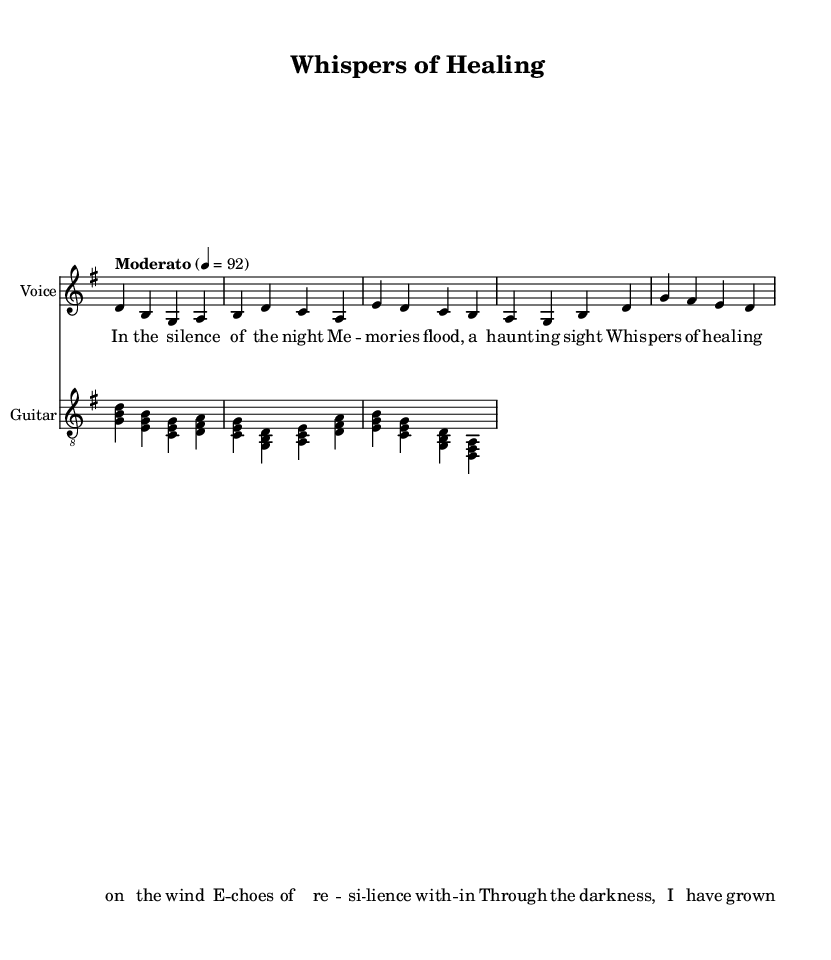What is the key signature of this music? The key signature is G major, which has one sharp (F#). This can be confirmed by looking at the key signature at the beginning of the score.
Answer: G major What is the time signature of this music? The time signature is 4/4, indicated by the notation present at the beginning of the piece. This means there are four beats in each measure.
Answer: 4/4 What is the tempo marking for this piece? The tempo marking indicates "Moderato," which generally suggests a moderate speed. It is specified in the tempo text above the staff, and the corresponding metronome marking is 92.
Answer: Moderato How many measures are in the verse? The verse consists of four measures. By counting the sets of vertical lines (bar lines) between the measures, we can determine there are four distinct measures present in the verse.
Answer: 4 What chord follows the G chord in the chorus? The chord that follows the G chord in the chorus is the A chord. This can be found by examining the chord symbols above the staff during the chorus section.
Answer: A Which instrument has lyrics associated with it? The voice part has lyrics associated with it. Lyrics are written in a separate line below the staff designated for the voice, while the guitar part does not have any lyrics.
Answer: Voice What theme is reflected in the lyrics of this song? The lyrics reflect themes of healing and resilience. This can be interpreted from phrases like "whispers of healing" and "echoes of resilience," which convey introspection and recovery.
Answer: Healing and resilience 